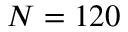Convert formula to latex. <formula><loc_0><loc_0><loc_500><loc_500>N = 1 2 0</formula> 